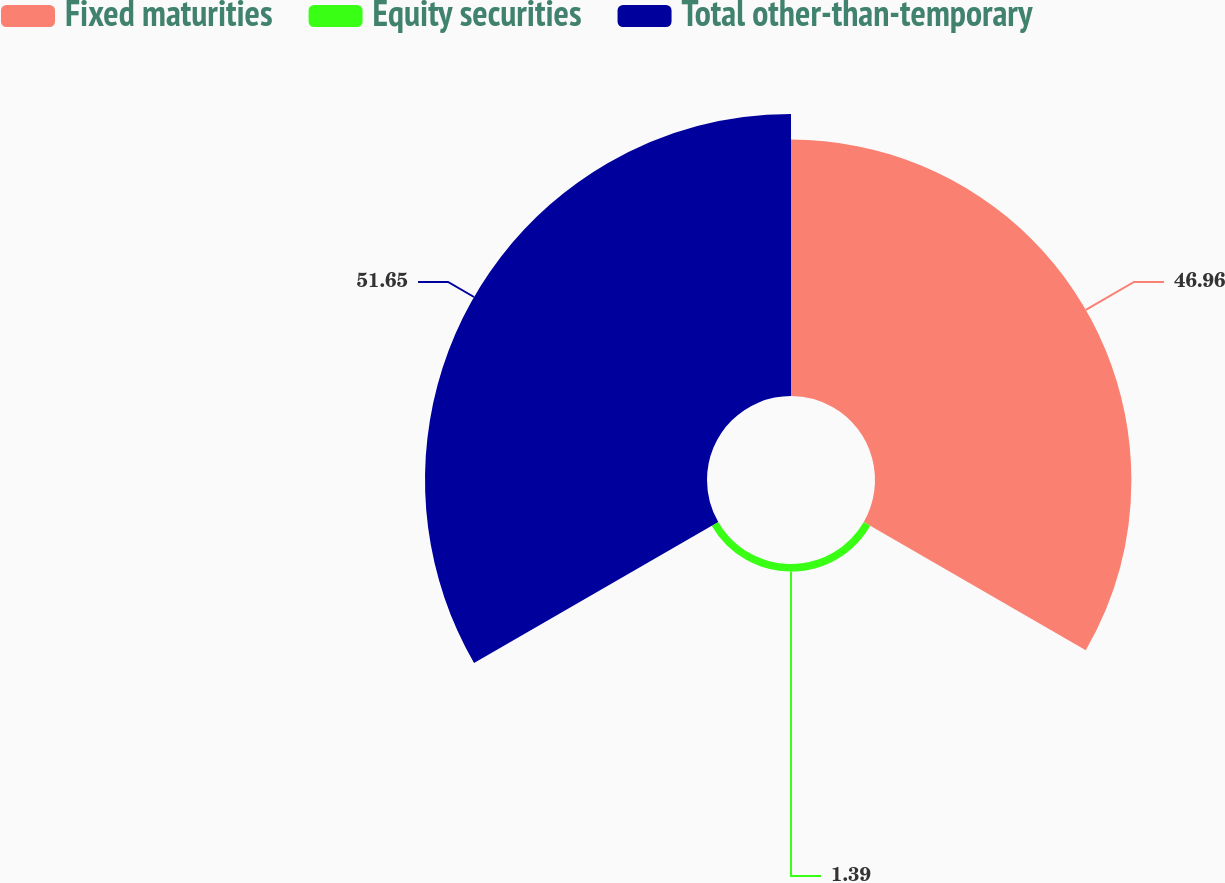Convert chart. <chart><loc_0><loc_0><loc_500><loc_500><pie_chart><fcel>Fixed maturities<fcel>Equity securities<fcel>Total other-than-temporary<nl><fcel>46.96%<fcel>1.39%<fcel>51.65%<nl></chart> 